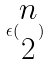Convert formula to latex. <formula><loc_0><loc_0><loc_500><loc_500>\epsilon ( \begin{matrix} n \\ 2 \end{matrix} )</formula> 